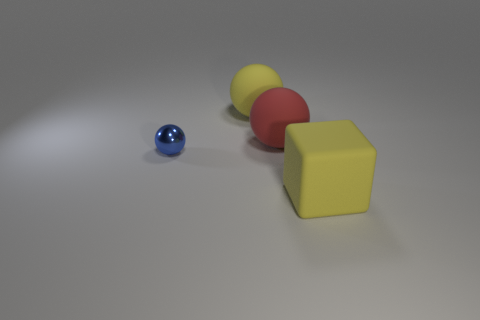Is there another block that has the same color as the big cube?
Offer a terse response. No. Is the number of big yellow matte things that are behind the yellow rubber block the same as the number of objects?
Provide a succinct answer. No. Is the metal thing the same color as the big block?
Your response must be concise. No. What is the size of the object that is both in front of the red ball and left of the large rubber block?
Provide a short and direct response. Small. There is another sphere that is made of the same material as the big yellow ball; what color is it?
Offer a very short reply. Red. What number of yellow objects have the same material as the big red thing?
Keep it short and to the point. 2. Is the number of big yellow matte spheres to the right of the big cube the same as the number of large rubber balls behind the large red sphere?
Give a very brief answer. No. There is a big red rubber object; does it have the same shape as the yellow object that is behind the block?
Keep it short and to the point. Yes. What material is the large object that is the same color as the big block?
Your answer should be compact. Rubber. Is there anything else that is the same shape as the tiny object?
Provide a short and direct response. Yes. 